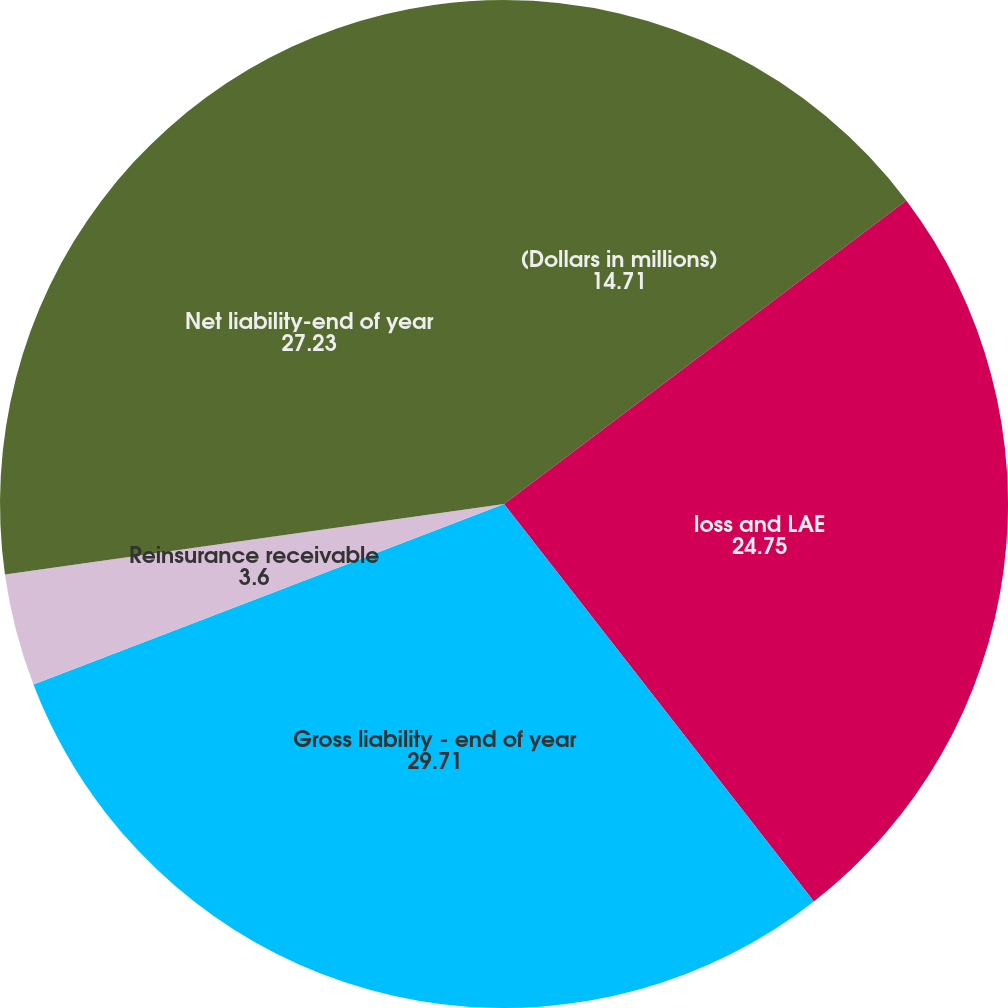<chart> <loc_0><loc_0><loc_500><loc_500><pie_chart><fcel>(Dollars in millions)<fcel>loss and LAE<fcel>Gross liability - end of year<fcel>Reinsurance receivable<fcel>Net liability-end of year<nl><fcel>14.71%<fcel>24.75%<fcel>29.71%<fcel>3.6%<fcel>27.23%<nl></chart> 